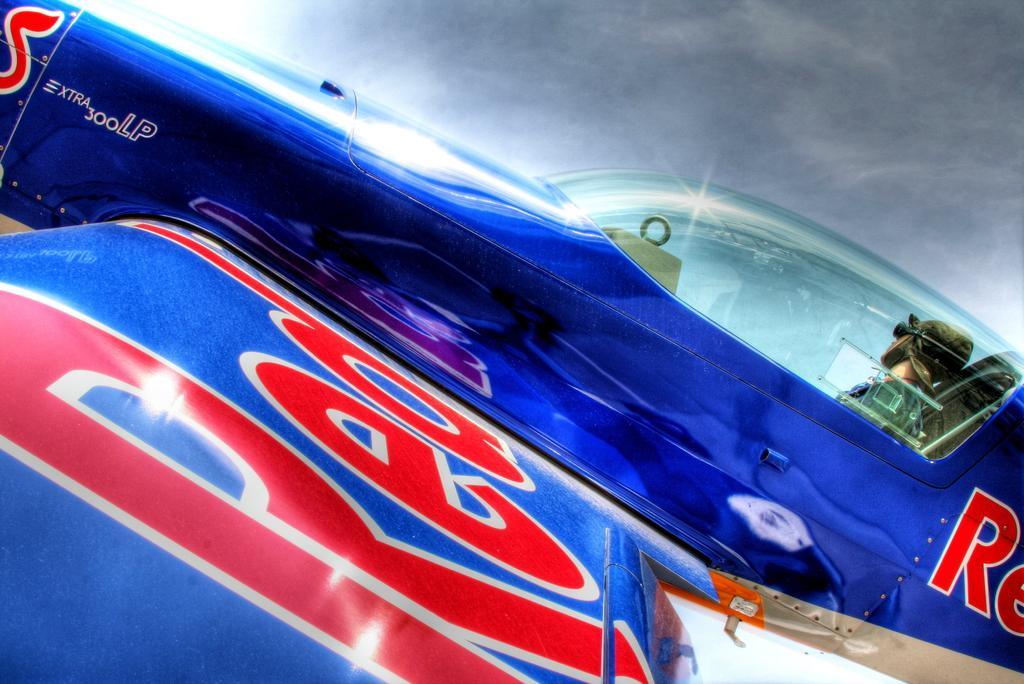<image>
Describe the image concisely. a car that has the word extra on it 